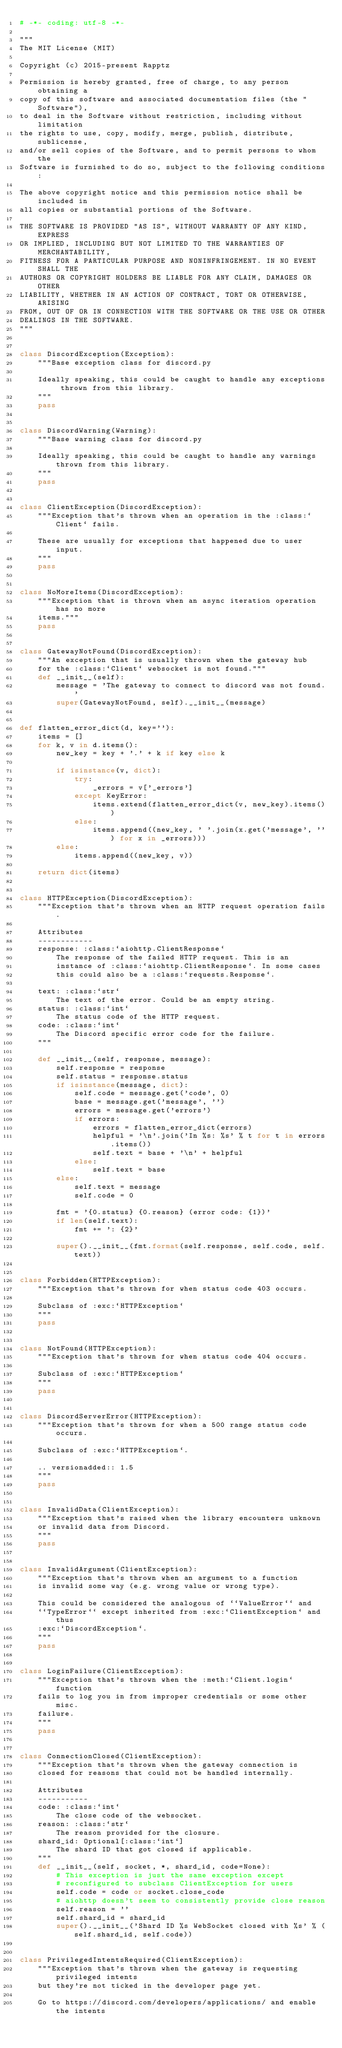Convert code to text. <code><loc_0><loc_0><loc_500><loc_500><_Python_># -*- coding: utf-8 -*-

"""
The MIT License (MIT)

Copyright (c) 2015-present Rapptz

Permission is hereby granted, free of charge, to any person obtaining a
copy of this software and associated documentation files (the "Software"),
to deal in the Software without restriction, including without limitation
the rights to use, copy, modify, merge, publish, distribute, sublicense,
and/or sell copies of the Software, and to permit persons to whom the
Software is furnished to do so, subject to the following conditions:

The above copyright notice and this permission notice shall be included in
all copies or substantial portions of the Software.

THE SOFTWARE IS PROVIDED "AS IS", WITHOUT WARRANTY OF ANY KIND, EXPRESS
OR IMPLIED, INCLUDING BUT NOT LIMITED TO THE WARRANTIES OF MERCHANTABILITY,
FITNESS FOR A PARTICULAR PURPOSE AND NONINFRINGEMENT. IN NO EVENT SHALL THE
AUTHORS OR COPYRIGHT HOLDERS BE LIABLE FOR ANY CLAIM, DAMAGES OR OTHER
LIABILITY, WHETHER IN AN ACTION OF CONTRACT, TORT OR OTHERWISE, ARISING
FROM, OUT OF OR IN CONNECTION WITH THE SOFTWARE OR THE USE OR OTHER
DEALINGS IN THE SOFTWARE.
"""


class DiscordException(Exception):
    """Base exception class for discord.py

    Ideally speaking, this could be caught to handle any exceptions thrown from this library.
    """
    pass


class DiscordWarning(Warning):
    """Base warning class for discord.py

    Ideally speaking, this could be caught to handle any warnings thrown from this library.
    """
    pass


class ClientException(DiscordException):
    """Exception that's thrown when an operation in the :class:`Client` fails.

    These are usually for exceptions that happened due to user input.
    """
    pass


class NoMoreItems(DiscordException):
    """Exception that is thrown when an async iteration operation has no more
    items."""
    pass


class GatewayNotFound(DiscordException):
    """An exception that is usually thrown when the gateway hub
    for the :class:`Client` websocket is not found."""
    def __init__(self):
        message = 'The gateway to connect to discord was not found.'
        super(GatewayNotFound, self).__init__(message)


def flatten_error_dict(d, key=''):
    items = []
    for k, v in d.items():
        new_key = key + '.' + k if key else k

        if isinstance(v, dict):
            try:
                _errors = v['_errors']
            except KeyError:
                items.extend(flatten_error_dict(v, new_key).items())
            else:
                items.append((new_key, ' '.join(x.get('message', '') for x in _errors)))
        else:
            items.append((new_key, v))

    return dict(items)


class HTTPException(DiscordException):
    """Exception that's thrown when an HTTP request operation fails.

    Attributes
    ------------
    response: :class:`aiohttp.ClientResponse`
        The response of the failed HTTP request. This is an
        instance of :class:`aiohttp.ClientResponse`. In some cases
        this could also be a :class:`requests.Response`.

    text: :class:`str`
        The text of the error. Could be an empty string.
    status: :class:`int`
        The status code of the HTTP request.
    code: :class:`int`
        The Discord specific error code for the failure.
    """

    def __init__(self, response, message):
        self.response = response
        self.status = response.status
        if isinstance(message, dict):
            self.code = message.get('code', 0)
            base = message.get('message', '')
            errors = message.get('errors')
            if errors:
                errors = flatten_error_dict(errors)
                helpful = '\n'.join('In %s: %s' % t for t in errors.items())
                self.text = base + '\n' + helpful
            else:
                self.text = base
        else:
            self.text = message
            self.code = 0

        fmt = '{0.status} {0.reason} (error code: {1})'
        if len(self.text):
            fmt += ': {2}'

        super().__init__(fmt.format(self.response, self.code, self.text))


class Forbidden(HTTPException):
    """Exception that's thrown for when status code 403 occurs.

    Subclass of :exc:`HTTPException`
    """
    pass


class NotFound(HTTPException):
    """Exception that's thrown for when status code 404 occurs.

    Subclass of :exc:`HTTPException`
    """
    pass


class DiscordServerError(HTTPException):
    """Exception that's thrown for when a 500 range status code occurs.

    Subclass of :exc:`HTTPException`.

    .. versionadded:: 1.5
    """
    pass


class InvalidData(ClientException):
    """Exception that's raised when the library encounters unknown
    or invalid data from Discord.
    """
    pass


class InvalidArgument(ClientException):
    """Exception that's thrown when an argument to a function
    is invalid some way (e.g. wrong value or wrong type).

    This could be considered the analogous of ``ValueError`` and
    ``TypeError`` except inherited from :exc:`ClientException` and thus
    :exc:`DiscordException`.
    """
    pass


class LoginFailure(ClientException):
    """Exception that's thrown when the :meth:`Client.login` function
    fails to log you in from improper credentials or some other misc.
    failure.
    """
    pass


class ConnectionClosed(ClientException):
    """Exception that's thrown when the gateway connection is
    closed for reasons that could not be handled internally.

    Attributes
    -----------
    code: :class:`int`
        The close code of the websocket.
    reason: :class:`str`
        The reason provided for the closure.
    shard_id: Optional[:class:`int`]
        The shard ID that got closed if applicable.
    """
    def __init__(self, socket, *, shard_id, code=None):
        # This exception is just the same exception except
        # reconfigured to subclass ClientException for users
        self.code = code or socket.close_code
        # aiohttp doesn't seem to consistently provide close reason
        self.reason = ''
        self.shard_id = shard_id
        super().__init__('Shard ID %s WebSocket closed with %s' % (self.shard_id, self.code))


class PrivilegedIntentsRequired(ClientException):
    """Exception that's thrown when the gateway is requesting privileged intents
    but they're not ticked in the developer page yet.

    Go to https://discord.com/developers/applications/ and enable the intents</code> 